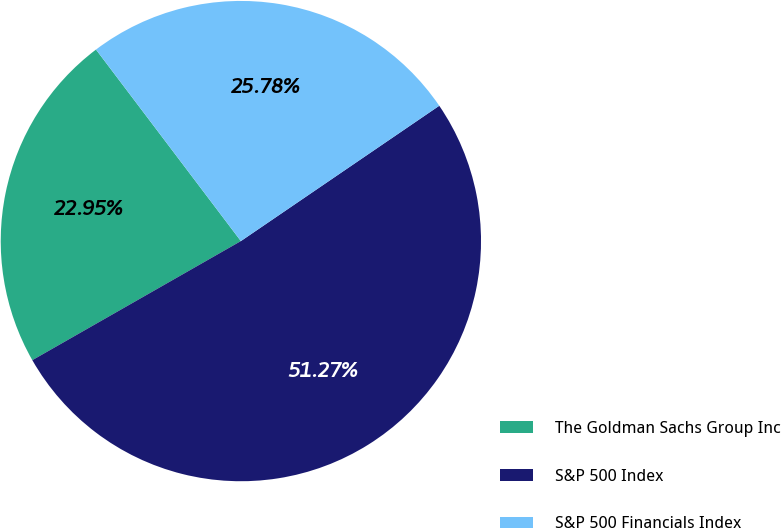Convert chart. <chart><loc_0><loc_0><loc_500><loc_500><pie_chart><fcel>The Goldman Sachs Group Inc<fcel>S&P 500 Index<fcel>S&P 500 Financials Index<nl><fcel>22.95%<fcel>51.27%<fcel>25.78%<nl></chart> 